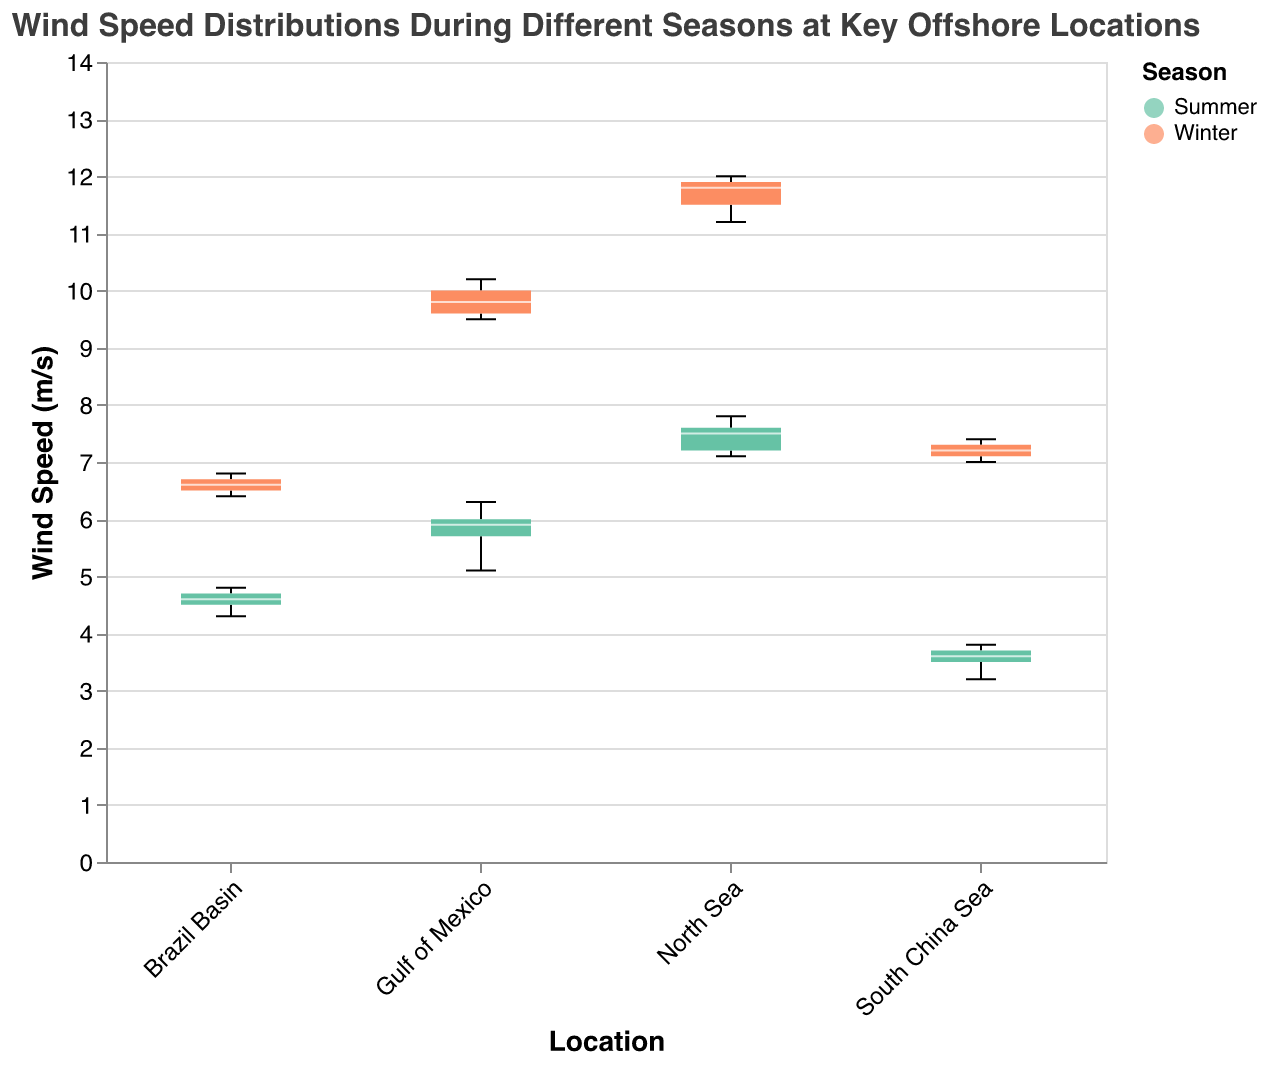What is the title of the plot? The title of the plot is given at the top of the figure.
Answer: Wind Speed Distributions During Different Seasons at Key Offshore Locations How many locations are represented in the plot? The x-axis displays the different locations represented in the figure.
Answer: 4 Which season has a higher median wind speed in the Gulf of Mexico? The color of the notches and the position of the median line indicate the median wind speed for each season.
Answer: Winter What is the range of wind speeds in the North Sea during winter? The range of wind speeds is shown by the extent of the whiskers for the respective season.
Answer: 11.2 - 12.0 m/s Which location has the lowest median wind speed in summer? Compare the median lines of the notched boxes for each location during summer.
Answer: South China Sea Which location shows the largest variation in wind speed during summer? The variation can be assessed by looking at the length of the interquartile range (IQR) and whiskers in the notched boxes for summer.
Answer: North Sea What is the difference in median wind speeds between summer and winter in the Gulf of Mexico? Identify the median lines for both seasons in the Gulf of Mexico and subtract the summer median from the winter median.
Answer: 4.0 m/s In which season is the median wind speed higher for every location? Compare the median lines of notched boxes for all locations across both seasons.
Answer: Winter Are there any outliers in the data? If yes, in which locations? Outliers are points outside the whiskers. Check for such points in the notched boxes.
Answer: No What is the median wind speed in the South China Sea during winter? The median wind speed for the South China Sea in winter is indicated by the horizontal line inside the notched box.
Answer: 7.2 m/s 